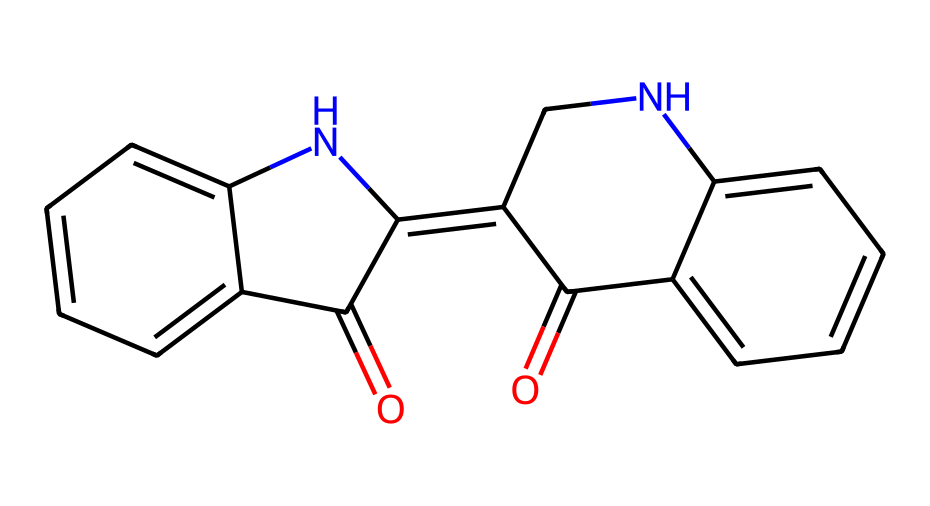What is the molecular formula for indigo? The SMILES representation indicates the presence of specific atoms: carbon (C), nitrogen (N), and oxygen (O). Analyzing the structure, we count the atoms: there are 16 carbon atoms, 2 nitrogen atoms, and 2 oxygen atoms, leading to the molecular formula C16H10N2O2.
Answer: C16H10N2O2 How many rings are present in the structure of indigo? The SMILES notation reveals the cyclic nature of the molecule through the use of numbers indicating ring closures. In this case, there are 2 ring closures (C1 and C2), indicating that there are 2 distinct rings in the structure.
Answer: 2 What type of chemical compound is indigo? Indigo is classified as a dye due to its application in coloring textiles and other materials. Moreover, since it contains nitrogen, it's also categorized as an organic compound.
Answer: dye What feature of indigo contributes to its color? The extended conjugated system of alternating double bonds in the structure absorbs specific wavelengths of light, which contributes to indigo's characteristic blue color. This feature is central in dyes that typically show colors in the visible spectrum.
Answer: conjugated system How many nitrogen atoms are in indigo? By examining the SMILES notation, we can identify nitrogen atoms indicated by the "N" symbols. There are two distinct instances of "N" in the representation, leading to the conclusion that there are 2 nitrogen atoms present in indigo.
Answer: 2 What functional groups are present in indigo? The structure of indigo contains carbonyl groups (C=O) as part of its amine and aromatic structure. Each carbonyl contributes to the overall properties of the dye, such as solubility and color intensity. Identifying these means looking for the relevant oxygen atoms in the representation.
Answer: carbonyl groups 